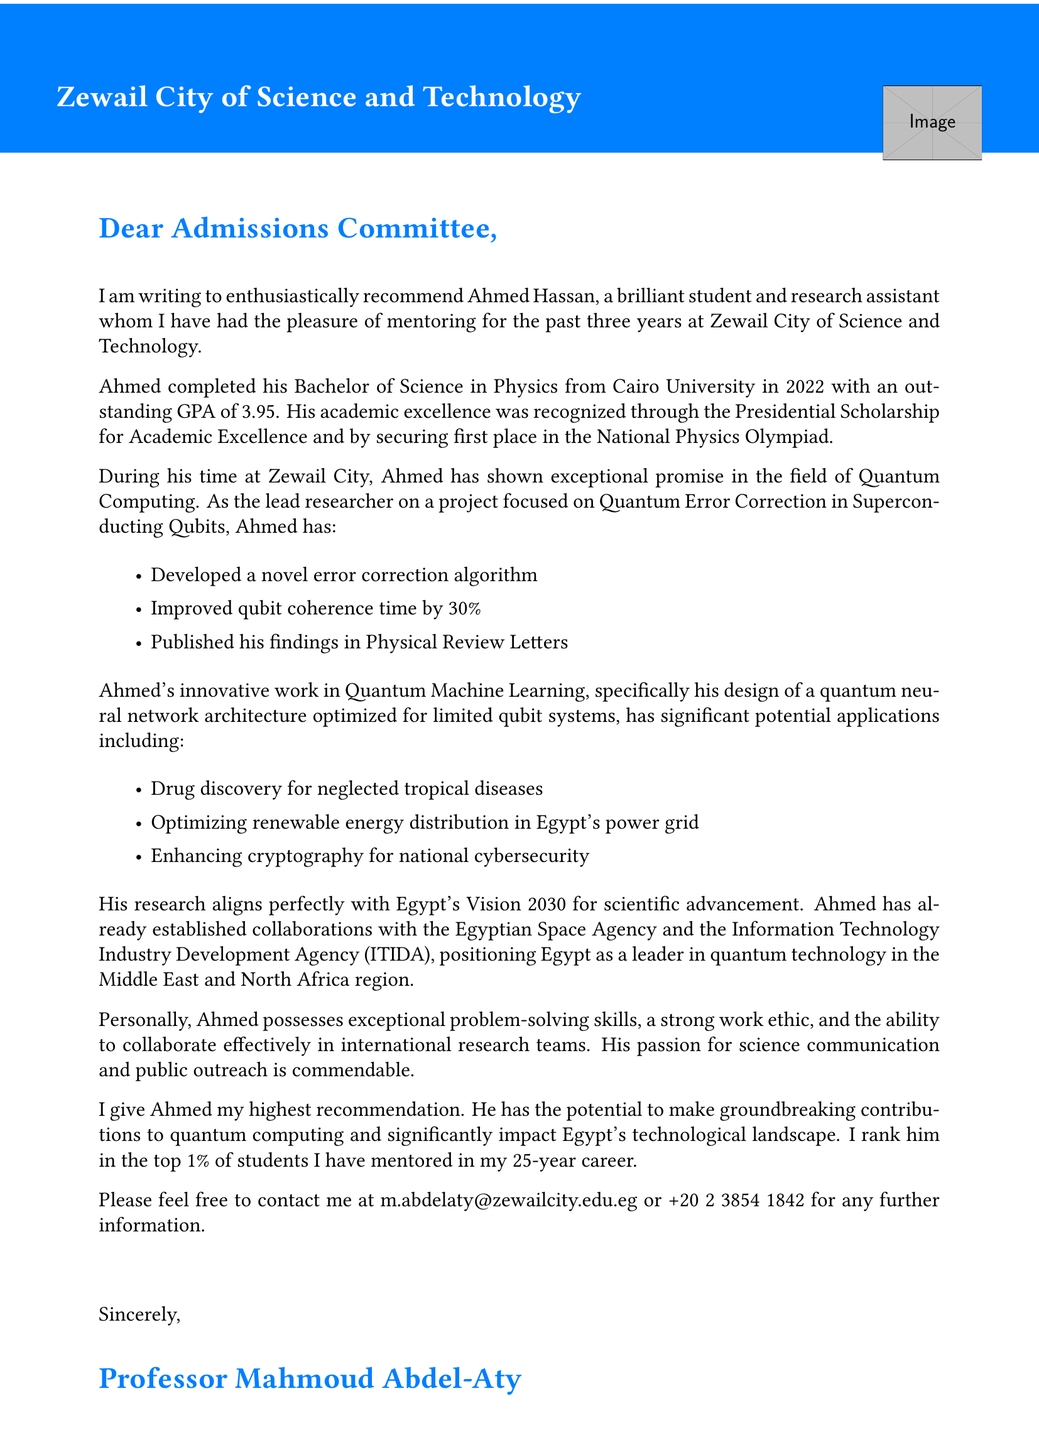What is the name of the recommended person? The document states that the recommended person is Ahmed Hassan.
Answer: Ahmed Hassan What is Ahmed's GPA? The document lists Ahmed's GPA as 3.95.
Answer: 3.95 Which project did Ahmed lead as a researcher? The project that Ahmed led is titled "Quantum Error Correction in Superconducting Qubits."
Answer: Quantum Error Correction in Superconducting Qubits What significant improvement did Ahmed achieve in qubit coherence time? The document mentions that Ahmed improved qubit coherence time by 30%.
Answer: 30% What is the title of the person recommending Ahmed? The document indicates that the recommending person holds the title of Chair of Physics Department.
Answer: Chair of Physics Department What is the relevance of Ahmed's work to Egypt? The document notes that Ahmed's work aligns with Egypt's Vision 2030 for scientific advancement.
Answer: Egypt's Vision 2030 In how many years has the recommender been mentoring students? The document specifies that the recommender has been mentoring students for 25 years.
Answer: 25 years What is one potential application of Ahmed's work mentioned in the letter? The letter lists multiple applications, one being drug discovery for neglected tropical diseases.
Answer: Drug discovery for neglected tropical diseases What is the email address provided for further contact? The document provides the email address m.abdelaty@zewailcity.edu.eg for contact.
Answer: m.abdelaty@zewailcity.edu.eg 